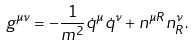<formula> <loc_0><loc_0><loc_500><loc_500>g ^ { \mu \nu } = - \frac { 1 } { m ^ { 2 } } \dot { q } ^ { \mu } \dot { q } ^ { \nu } + n ^ { \mu R } n ^ { \nu } _ { R } .</formula> 